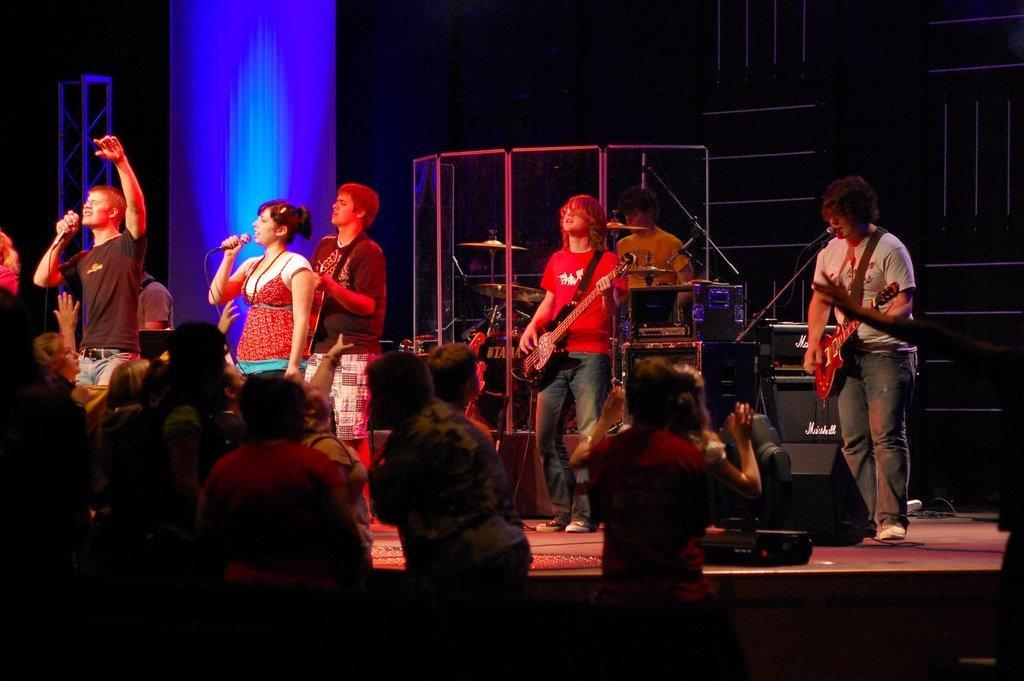Can you describe this image briefly? In this image I see lot of people standing on the stage and few people over here and few of them are holding mic and few of them are holding guitar. 